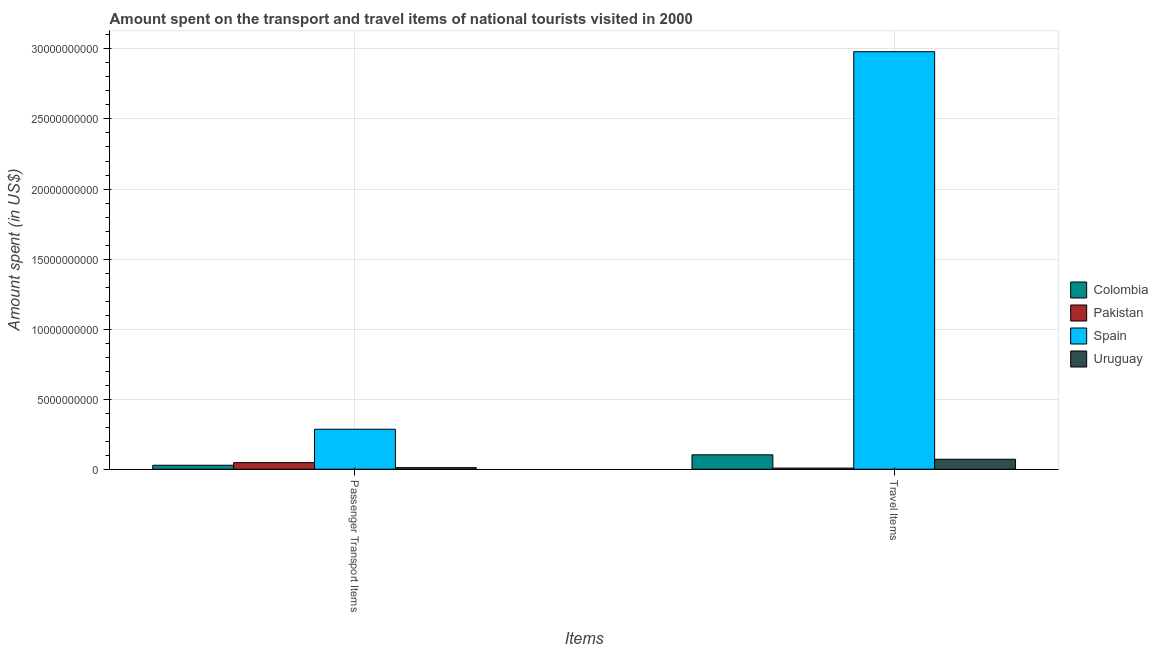How many groups of bars are there?
Make the answer very short. 2. Are the number of bars on each tick of the X-axis equal?
Ensure brevity in your answer.  Yes. How many bars are there on the 1st tick from the left?
Ensure brevity in your answer.  4. What is the label of the 2nd group of bars from the left?
Your answer should be compact. Travel Items. What is the amount spent on passenger transport items in Colombia?
Your answer should be very brief. 2.83e+08. Across all countries, what is the maximum amount spent in travel items?
Provide a succinct answer. 2.98e+1. Across all countries, what is the minimum amount spent on passenger transport items?
Give a very brief answer. 1.14e+08. In which country was the amount spent on passenger transport items minimum?
Offer a terse response. Uruguay. What is the total amount spent in travel items in the graph?
Your answer should be compact. 3.16e+1. What is the difference between the amount spent on passenger transport items in Colombia and that in Pakistan?
Offer a terse response. -1.87e+08. What is the difference between the amount spent in travel items in Spain and the amount spent on passenger transport items in Colombia?
Provide a succinct answer. 2.95e+1. What is the average amount spent in travel items per country?
Your answer should be very brief. 7.91e+09. What is the difference between the amount spent on passenger transport items and amount spent in travel items in Spain?
Your response must be concise. -2.69e+1. In how many countries, is the amount spent on passenger transport items greater than 6000000000 US$?
Offer a very short reply. 0. What is the ratio of the amount spent in travel items in Spain to that in Pakistan?
Your response must be concise. 367.93. What does the 1st bar from the right in Passenger Transport Items represents?
Offer a terse response. Uruguay. Are all the bars in the graph horizontal?
Your response must be concise. No. How many countries are there in the graph?
Offer a terse response. 4. What is the difference between two consecutive major ticks on the Y-axis?
Ensure brevity in your answer.  5.00e+09. Does the graph contain any zero values?
Ensure brevity in your answer.  No. Does the graph contain grids?
Ensure brevity in your answer.  Yes. What is the title of the graph?
Provide a succinct answer. Amount spent on the transport and travel items of national tourists visited in 2000. Does "Bolivia" appear as one of the legend labels in the graph?
Provide a succinct answer. No. What is the label or title of the X-axis?
Provide a succinct answer. Items. What is the label or title of the Y-axis?
Your answer should be compact. Amount spent (in US$). What is the Amount spent (in US$) of Colombia in Passenger Transport Items?
Ensure brevity in your answer.  2.83e+08. What is the Amount spent (in US$) of Pakistan in Passenger Transport Items?
Offer a very short reply. 4.70e+08. What is the Amount spent (in US$) in Spain in Passenger Transport Items?
Your response must be concise. 2.85e+09. What is the Amount spent (in US$) of Uruguay in Passenger Transport Items?
Your response must be concise. 1.14e+08. What is the Amount spent (in US$) in Colombia in Travel Items?
Provide a succinct answer. 1.03e+09. What is the Amount spent (in US$) in Pakistan in Travel Items?
Your answer should be very brief. 8.10e+07. What is the Amount spent (in US$) of Spain in Travel Items?
Give a very brief answer. 2.98e+1. What is the Amount spent (in US$) of Uruguay in Travel Items?
Offer a terse response. 7.13e+08. Across all Items, what is the maximum Amount spent (in US$) in Colombia?
Offer a very short reply. 1.03e+09. Across all Items, what is the maximum Amount spent (in US$) in Pakistan?
Make the answer very short. 4.70e+08. Across all Items, what is the maximum Amount spent (in US$) in Spain?
Offer a very short reply. 2.98e+1. Across all Items, what is the maximum Amount spent (in US$) of Uruguay?
Your response must be concise. 7.13e+08. Across all Items, what is the minimum Amount spent (in US$) of Colombia?
Provide a short and direct response. 2.83e+08. Across all Items, what is the minimum Amount spent (in US$) in Pakistan?
Offer a terse response. 8.10e+07. Across all Items, what is the minimum Amount spent (in US$) in Spain?
Your answer should be very brief. 2.85e+09. Across all Items, what is the minimum Amount spent (in US$) of Uruguay?
Provide a succinct answer. 1.14e+08. What is the total Amount spent (in US$) of Colombia in the graph?
Keep it short and to the point. 1.31e+09. What is the total Amount spent (in US$) in Pakistan in the graph?
Provide a short and direct response. 5.51e+08. What is the total Amount spent (in US$) in Spain in the graph?
Offer a very short reply. 3.27e+1. What is the total Amount spent (in US$) in Uruguay in the graph?
Your answer should be compact. 8.27e+08. What is the difference between the Amount spent (in US$) in Colombia in Passenger Transport Items and that in Travel Items?
Keep it short and to the point. -7.47e+08. What is the difference between the Amount spent (in US$) in Pakistan in Passenger Transport Items and that in Travel Items?
Your answer should be compact. 3.89e+08. What is the difference between the Amount spent (in US$) in Spain in Passenger Transport Items and that in Travel Items?
Provide a succinct answer. -2.69e+1. What is the difference between the Amount spent (in US$) of Uruguay in Passenger Transport Items and that in Travel Items?
Provide a succinct answer. -5.99e+08. What is the difference between the Amount spent (in US$) in Colombia in Passenger Transport Items and the Amount spent (in US$) in Pakistan in Travel Items?
Offer a very short reply. 2.02e+08. What is the difference between the Amount spent (in US$) of Colombia in Passenger Transport Items and the Amount spent (in US$) of Spain in Travel Items?
Ensure brevity in your answer.  -2.95e+1. What is the difference between the Amount spent (in US$) in Colombia in Passenger Transport Items and the Amount spent (in US$) in Uruguay in Travel Items?
Your answer should be very brief. -4.30e+08. What is the difference between the Amount spent (in US$) in Pakistan in Passenger Transport Items and the Amount spent (in US$) in Spain in Travel Items?
Keep it short and to the point. -2.93e+1. What is the difference between the Amount spent (in US$) of Pakistan in Passenger Transport Items and the Amount spent (in US$) of Uruguay in Travel Items?
Keep it short and to the point. -2.43e+08. What is the difference between the Amount spent (in US$) in Spain in Passenger Transport Items and the Amount spent (in US$) in Uruguay in Travel Items?
Your answer should be compact. 2.14e+09. What is the average Amount spent (in US$) in Colombia per Items?
Make the answer very short. 6.56e+08. What is the average Amount spent (in US$) in Pakistan per Items?
Ensure brevity in your answer.  2.76e+08. What is the average Amount spent (in US$) of Spain per Items?
Give a very brief answer. 1.63e+1. What is the average Amount spent (in US$) in Uruguay per Items?
Offer a terse response. 4.14e+08. What is the difference between the Amount spent (in US$) in Colombia and Amount spent (in US$) in Pakistan in Passenger Transport Items?
Offer a very short reply. -1.87e+08. What is the difference between the Amount spent (in US$) in Colombia and Amount spent (in US$) in Spain in Passenger Transport Items?
Give a very brief answer. -2.57e+09. What is the difference between the Amount spent (in US$) of Colombia and Amount spent (in US$) of Uruguay in Passenger Transport Items?
Offer a very short reply. 1.69e+08. What is the difference between the Amount spent (in US$) in Pakistan and Amount spent (in US$) in Spain in Passenger Transport Items?
Your answer should be compact. -2.38e+09. What is the difference between the Amount spent (in US$) of Pakistan and Amount spent (in US$) of Uruguay in Passenger Transport Items?
Make the answer very short. 3.56e+08. What is the difference between the Amount spent (in US$) of Spain and Amount spent (in US$) of Uruguay in Passenger Transport Items?
Keep it short and to the point. 2.74e+09. What is the difference between the Amount spent (in US$) of Colombia and Amount spent (in US$) of Pakistan in Travel Items?
Provide a short and direct response. 9.49e+08. What is the difference between the Amount spent (in US$) of Colombia and Amount spent (in US$) of Spain in Travel Items?
Keep it short and to the point. -2.88e+1. What is the difference between the Amount spent (in US$) in Colombia and Amount spent (in US$) in Uruguay in Travel Items?
Offer a terse response. 3.17e+08. What is the difference between the Amount spent (in US$) of Pakistan and Amount spent (in US$) of Spain in Travel Items?
Provide a succinct answer. -2.97e+1. What is the difference between the Amount spent (in US$) in Pakistan and Amount spent (in US$) in Uruguay in Travel Items?
Offer a terse response. -6.32e+08. What is the difference between the Amount spent (in US$) in Spain and Amount spent (in US$) in Uruguay in Travel Items?
Give a very brief answer. 2.91e+1. What is the ratio of the Amount spent (in US$) in Colombia in Passenger Transport Items to that in Travel Items?
Offer a very short reply. 0.27. What is the ratio of the Amount spent (in US$) in Pakistan in Passenger Transport Items to that in Travel Items?
Your answer should be compact. 5.8. What is the ratio of the Amount spent (in US$) of Spain in Passenger Transport Items to that in Travel Items?
Ensure brevity in your answer.  0.1. What is the ratio of the Amount spent (in US$) of Uruguay in Passenger Transport Items to that in Travel Items?
Provide a short and direct response. 0.16. What is the difference between the highest and the second highest Amount spent (in US$) in Colombia?
Keep it short and to the point. 7.47e+08. What is the difference between the highest and the second highest Amount spent (in US$) of Pakistan?
Offer a terse response. 3.89e+08. What is the difference between the highest and the second highest Amount spent (in US$) in Spain?
Give a very brief answer. 2.69e+1. What is the difference between the highest and the second highest Amount spent (in US$) of Uruguay?
Ensure brevity in your answer.  5.99e+08. What is the difference between the highest and the lowest Amount spent (in US$) of Colombia?
Offer a very short reply. 7.47e+08. What is the difference between the highest and the lowest Amount spent (in US$) of Pakistan?
Provide a succinct answer. 3.89e+08. What is the difference between the highest and the lowest Amount spent (in US$) in Spain?
Offer a terse response. 2.69e+1. What is the difference between the highest and the lowest Amount spent (in US$) of Uruguay?
Provide a succinct answer. 5.99e+08. 